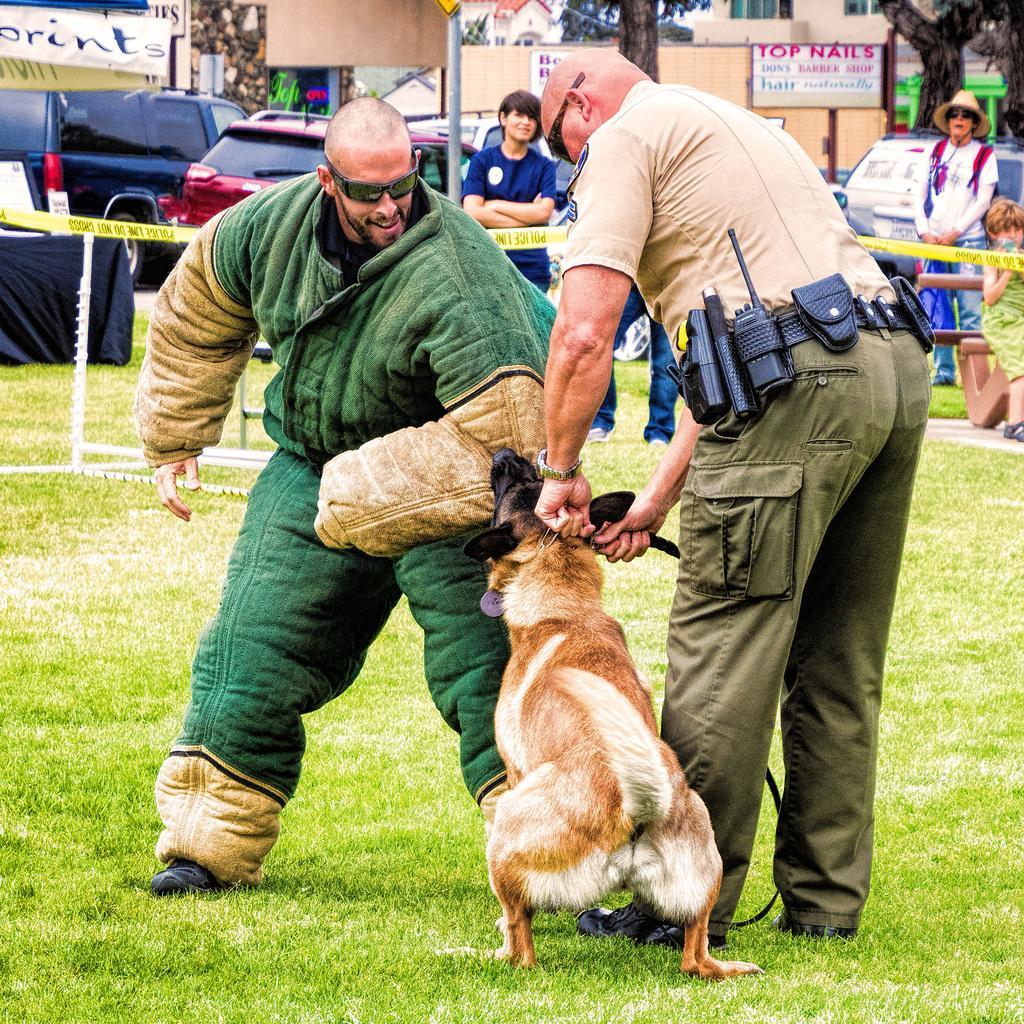How would you summarize this image in a sentence or two? In this image I can see two men are standing with a dog, I can see one of them is wearing uniform and both of them are wearing shades. In the background I can see few more people, vehicles, buildings and trees. 